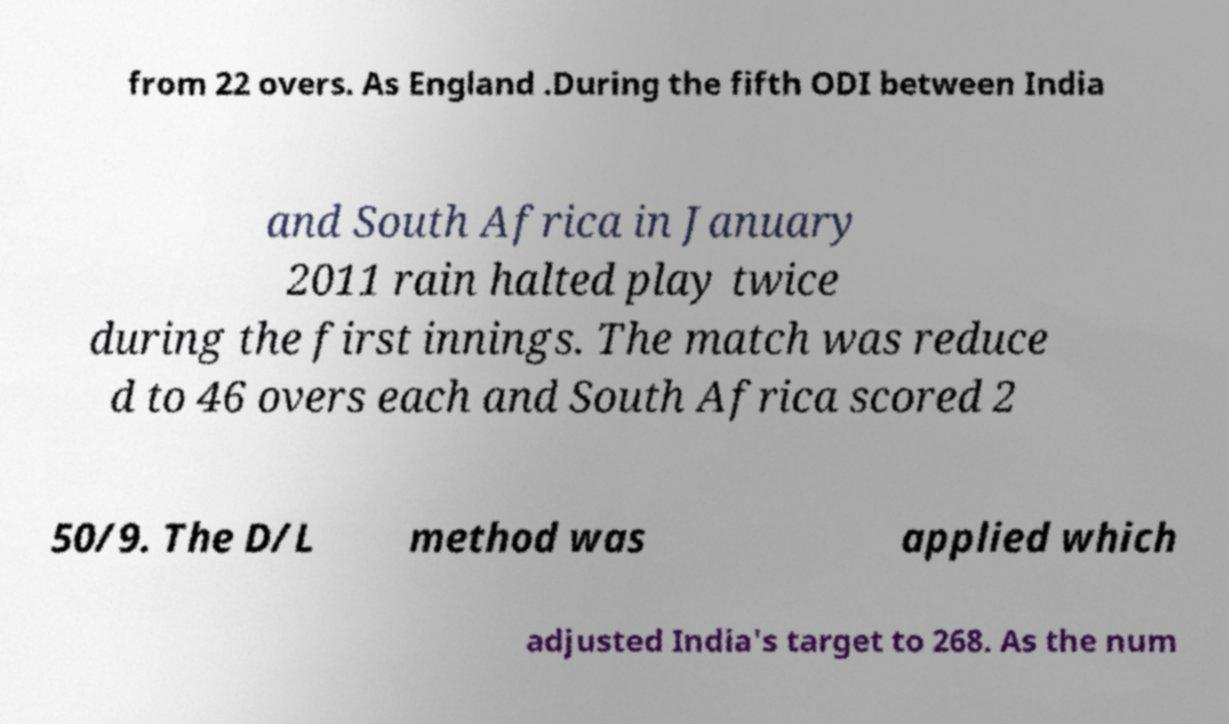Can you read and provide the text displayed in the image?This photo seems to have some interesting text. Can you extract and type it out for me? from 22 overs. As England .During the fifth ODI between India and South Africa in January 2011 rain halted play twice during the first innings. The match was reduce d to 46 overs each and South Africa scored 2 50/9. The D/L method was applied which adjusted India's target to 268. As the num 